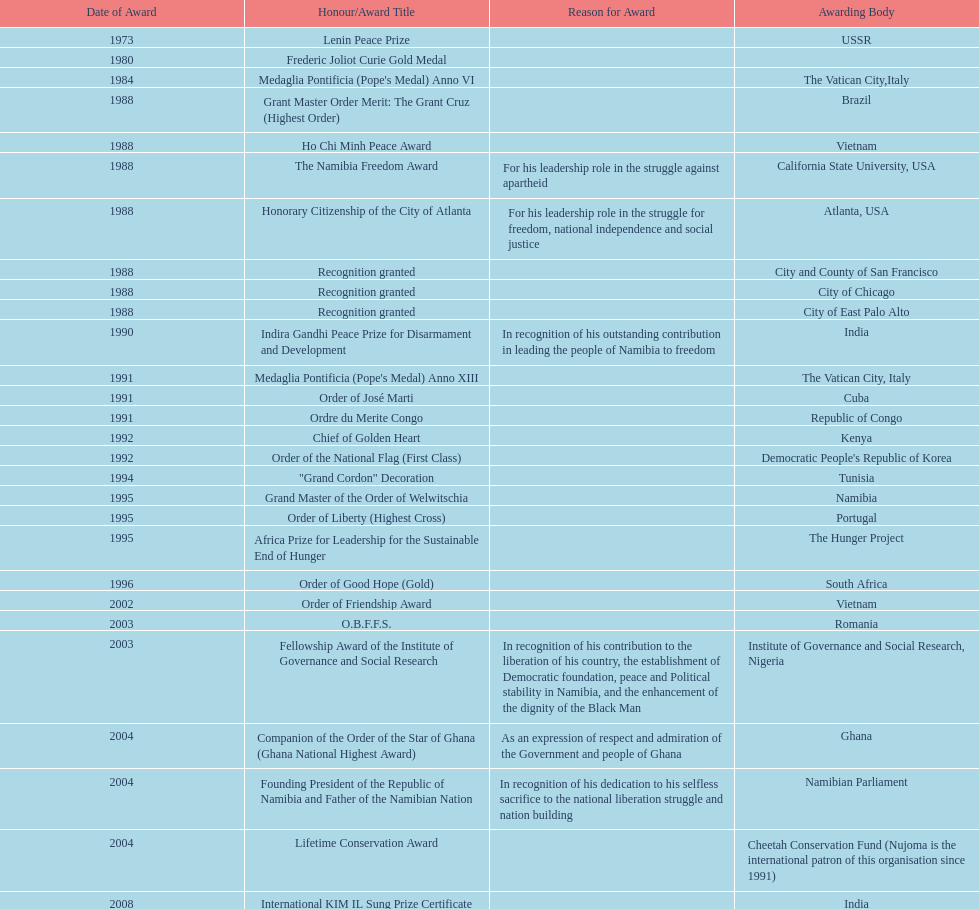What was the overall count of honors/award titles mentioned in this chart? 29. 